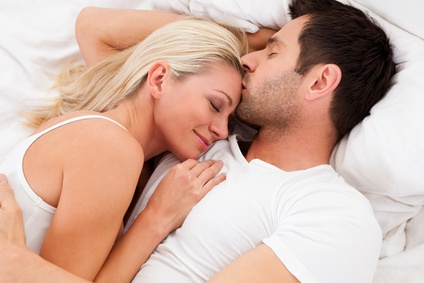Describe the objects in this image and their specific colors. I can see people in white, tan, salmon, and lightgray tones, people in white, black, tan, and salmon tones, and bed in white, lightgray, and darkgray tones in this image. 